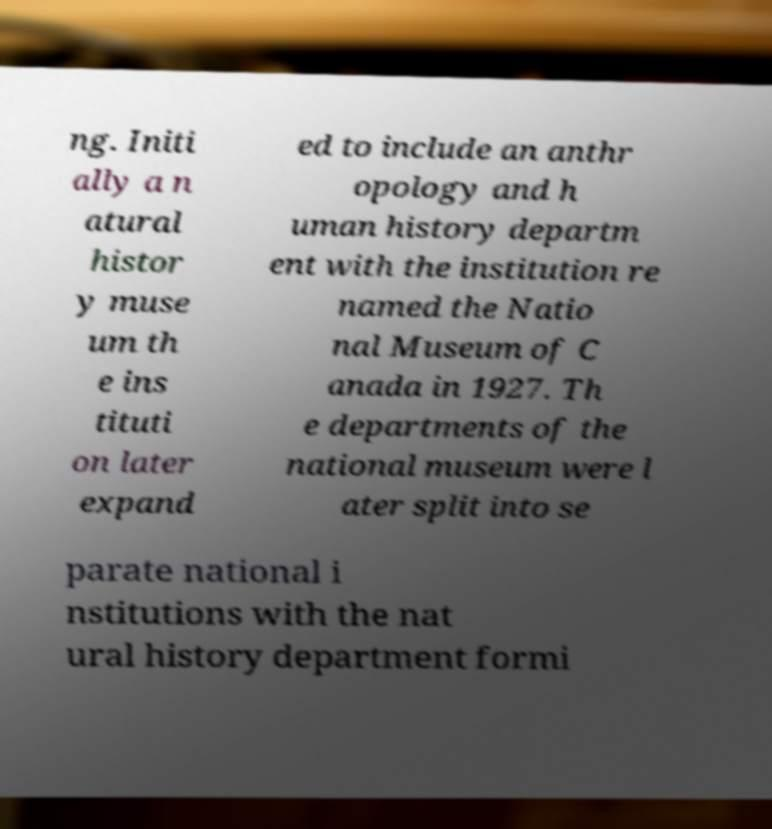What messages or text are displayed in this image? I need them in a readable, typed format. ng. Initi ally a n atural histor y muse um th e ins tituti on later expand ed to include an anthr opology and h uman history departm ent with the institution re named the Natio nal Museum of C anada in 1927. Th e departments of the national museum were l ater split into se parate national i nstitutions with the nat ural history department formi 